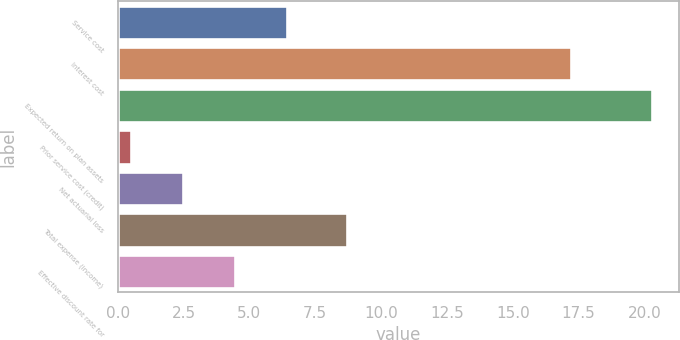Convert chart. <chart><loc_0><loc_0><loc_500><loc_500><bar_chart><fcel>Service cost<fcel>Interest cost<fcel>Expected return on plan assets<fcel>Prior service cost (credit)<fcel>Net actuarial loss<fcel>Total expense (income)<fcel>Effective discount rate for<nl><fcel>6.44<fcel>17.2<fcel>20.3<fcel>0.5<fcel>2.48<fcel>8.7<fcel>4.46<nl></chart> 